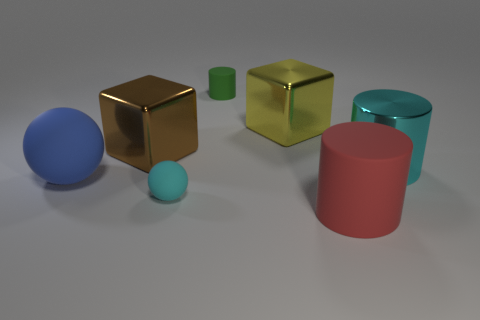What number of brown objects are tiny matte cylinders or shiny cylinders?
Make the answer very short. 0. What is the shape of the cyan object that is in front of the big cyan cylinder?
Provide a short and direct response. Sphere. What is the color of the other object that is the same size as the cyan rubber object?
Make the answer very short. Green. Do the big red thing and the cyan thing that is in front of the large cyan metal thing have the same shape?
Your response must be concise. No. What material is the cylinder on the left side of the matte cylinder in front of the cyan thing that is in front of the large cyan shiny thing made of?
Offer a terse response. Rubber. How many big things are yellow shiny blocks or gray metallic blocks?
Your answer should be very brief. 1. What number of other things are the same size as the red matte object?
Your answer should be compact. 4. Does the tiny thing behind the cyan shiny object have the same shape as the big yellow object?
Ensure brevity in your answer.  No. The small thing that is the same shape as the large cyan metallic object is what color?
Your response must be concise. Green. Is there anything else that has the same shape as the yellow object?
Make the answer very short. Yes. 